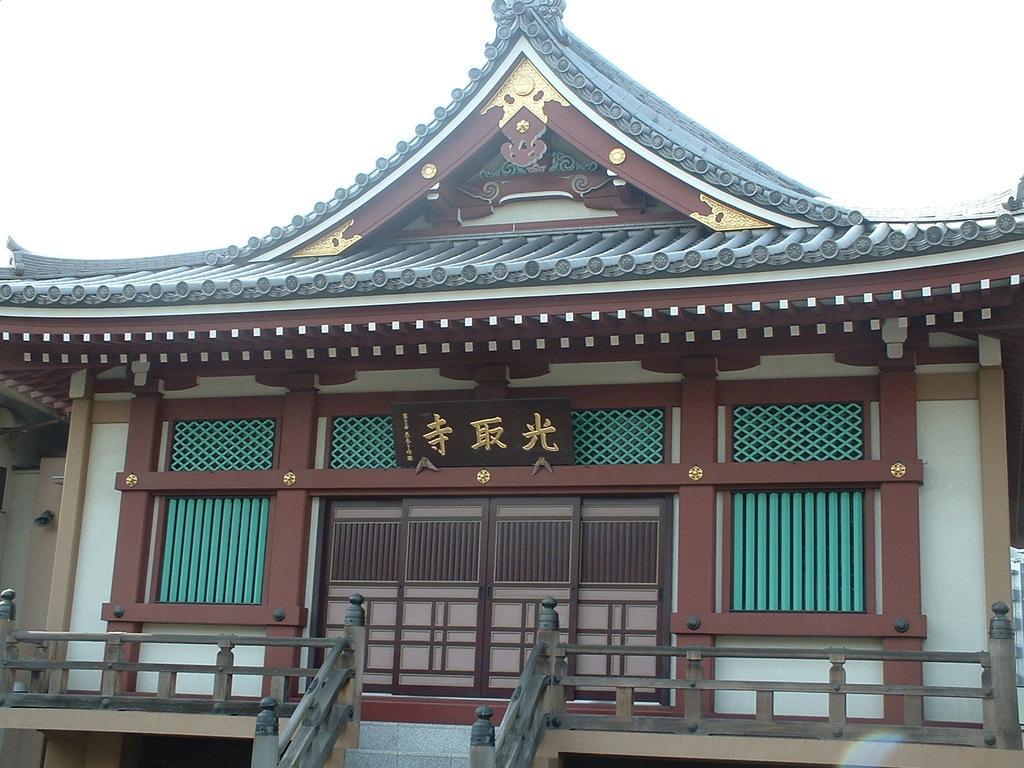Can you describe this image briefly? In the center of the image there is a building. In the background there is sky. 